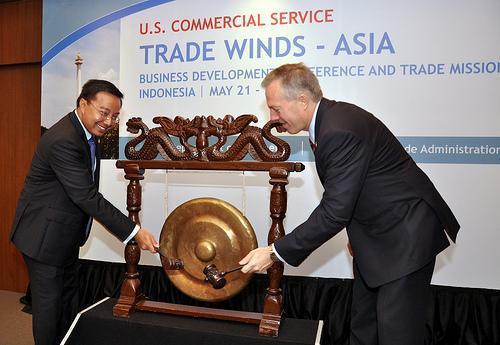How many peope are there?
Give a very brief answer. 2. 